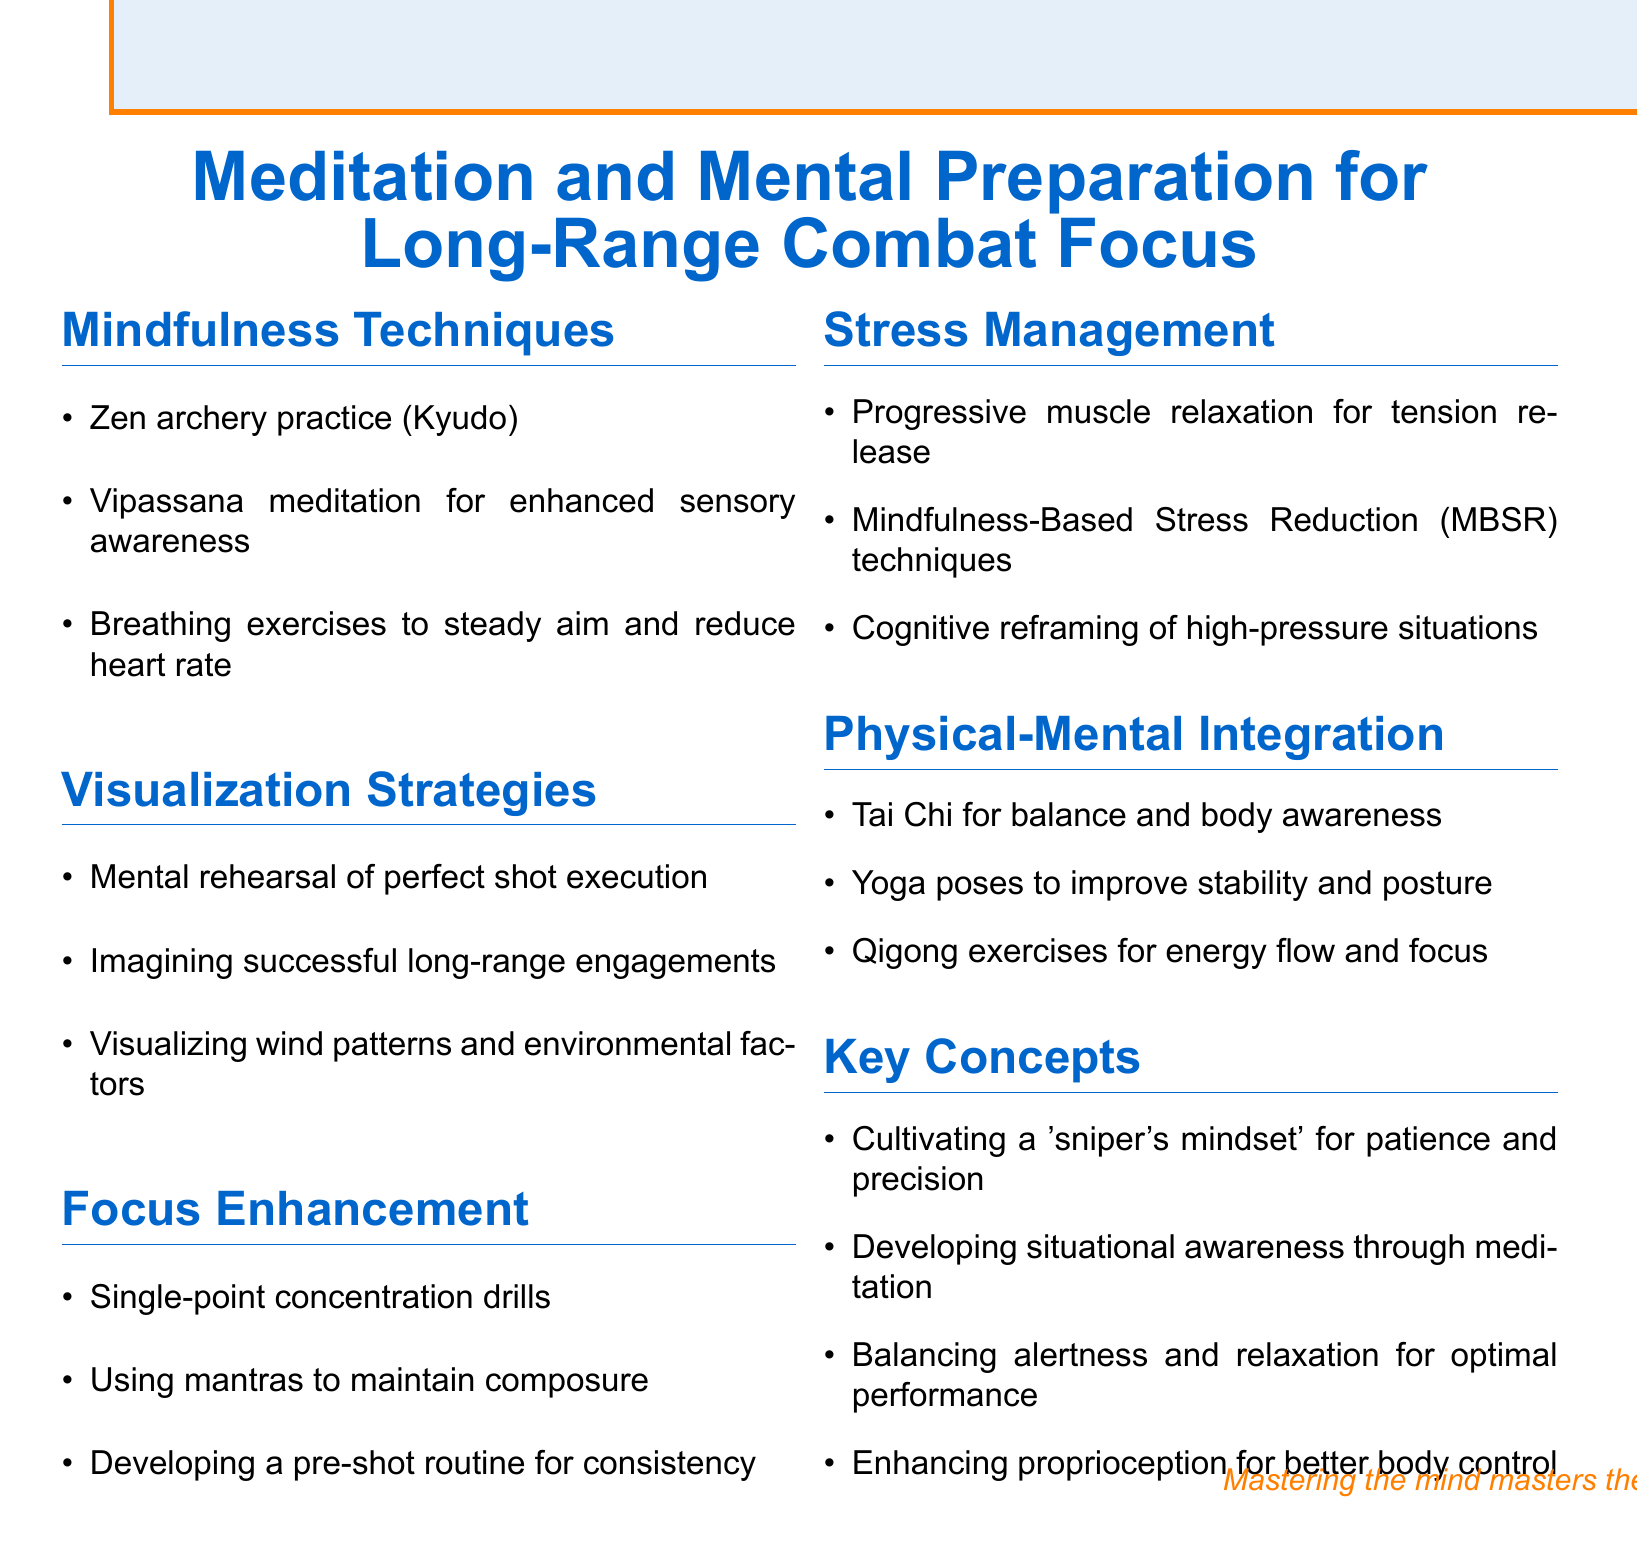What is the title of the document? The title of the document specifies the main topic covered, which is focused on meditation and mental preparation for long-range combat.
Answer: Meditation and Mental Preparation for Long-Range Combat Focus How many sections are in the document? The document consists of different sections that cover various techniques and concepts, with a total of five distinct sections.
Answer: 5 What practice is mentioned under Mindfulness Techniques that relates to archery? This practice specifically connects mindfulness with the skill of archery, emphasizing the importance of focus and precision.
Answer: Zen archery practice (Kyudo) What visualization strategy involves environmental factors? This strategy emphasizes the importance of understanding external elements that affect performance during long-range combat.
Answer: Visualizing wind patterns and environmental factors What is one key concept emphasized in the document? This concept highlights the mental state required for effective long-range combat, specifically focusing on patience and precision.
Answer: Cultivating a 'sniper's mindset' for patience and precision What technique is suggested for stress management? This technique focuses on physical relaxation methods aimed at reducing overall tension and improving performance under pressure.
Answer: Progressive muscle relaxation for tension release What is a focus enhancement method mentioned in the document? This method aims to improve concentration, ensuring that practitioners maintain their focus during critical moments.
Answer: Single-point concentration drills Which physical practice is recommended for balance and body awareness? This practice combines movement and mindfulness, enhancing both physical stability and mental clarity vital for combat situations.
Answer: Tai Chi for balance and body awareness 